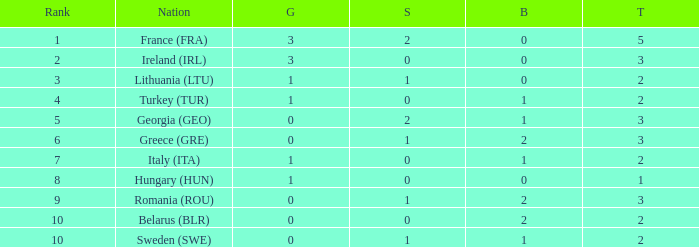What's the total of rank 8 when Silver medals are 0 and gold is more than 1? 0.0. 